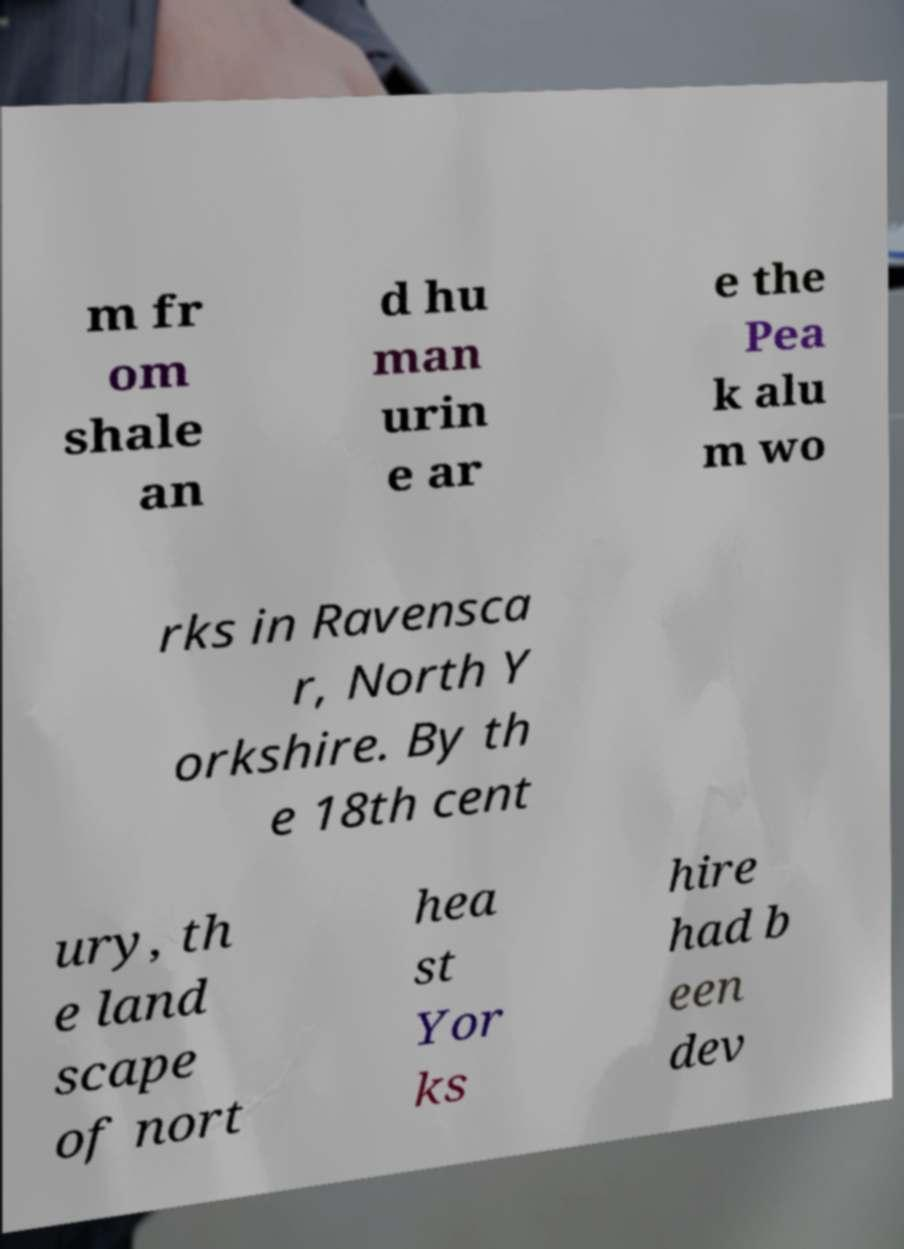Could you extract and type out the text from this image? m fr om shale an d hu man urin e ar e the Pea k alu m wo rks in Ravensca r, North Y orkshire. By th e 18th cent ury, th e land scape of nort hea st Yor ks hire had b een dev 